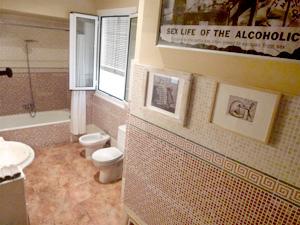Is this a restaurant toilet?
Write a very short answer. No. What does the large print depict?
Write a very short answer. Sex life of alcoholic. What kind of notice is taped to the wall?
Keep it brief. Sex life of alcoholic. Is this room carpeted?
Short answer required. No. What designs are on the wall?
Be succinct. Squares. Not counting the one in the mirror how many paintings are there?
Short answer required. 3. What is the color of the wall that's been painted?
Give a very brief answer. Yellow. Have the bathroom fixtures been updated in the last 5 years?
Short answer required. Yes. Is this a wide-angle perspective?
Give a very brief answer. Yes. Are there tiles on the wall?
Quick response, please. Yes. 